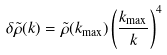<formula> <loc_0><loc_0><loc_500><loc_500>\delta \tilde { \rho } ( k ) = \tilde { \rho } ( k _ { \max } ) \left ( \frac { k _ { \max } } { k } \right ) ^ { 4 }</formula> 